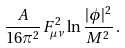<formula> <loc_0><loc_0><loc_500><loc_500>\frac { A } { 1 6 \pi ^ { 2 } } F ^ { 2 } _ { \mu \nu } \ln \frac { | \phi | ^ { 2 } } { M ^ { 2 } } \, .</formula> 